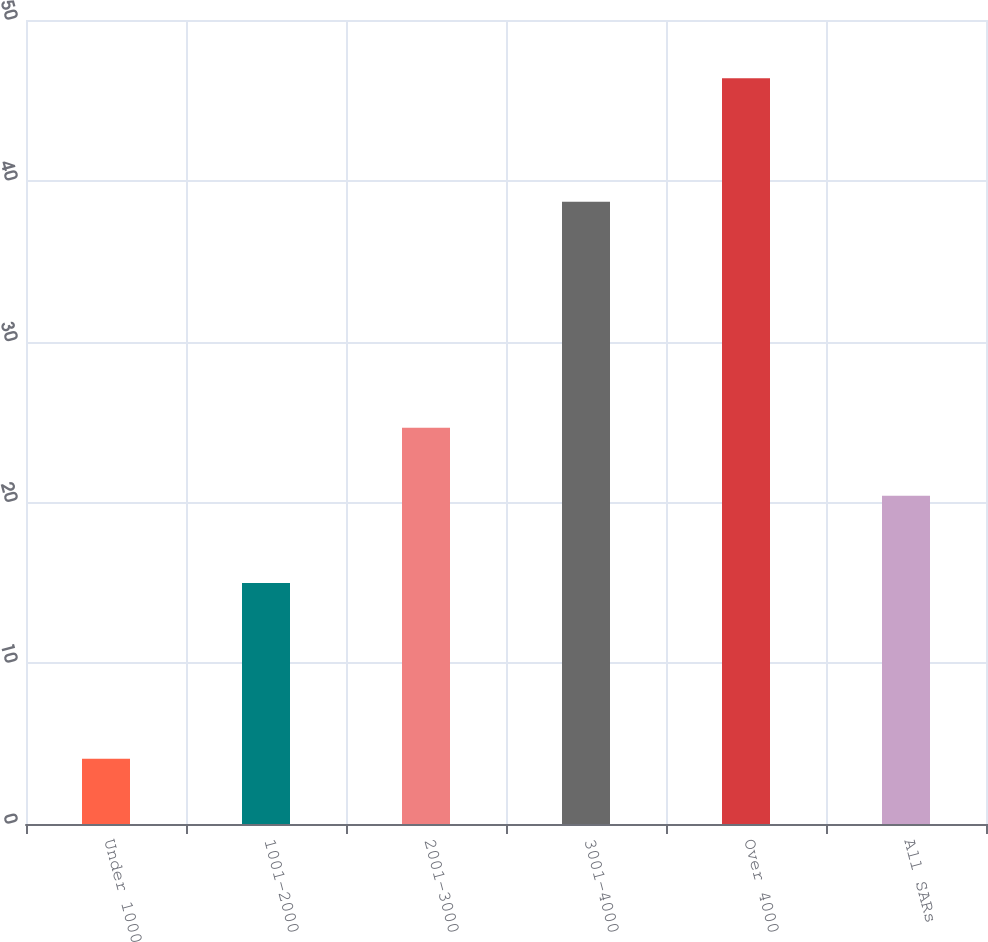<chart> <loc_0><loc_0><loc_500><loc_500><bar_chart><fcel>Under 1000<fcel>1001-2000<fcel>2001-3000<fcel>3001-4000<fcel>Over 4000<fcel>All SARs<nl><fcel>4.06<fcel>14.98<fcel>24.64<fcel>38.69<fcel>46.37<fcel>20.41<nl></chart> 